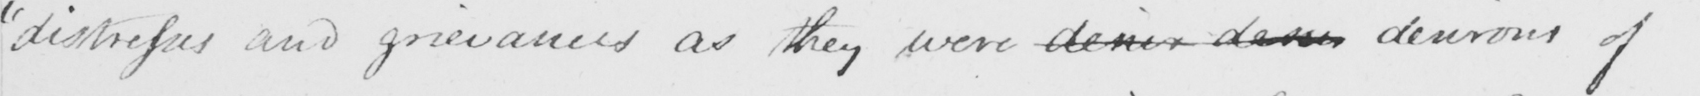What text is written in this handwritten line? " distresses and grievances as they were desier desire desirous of 